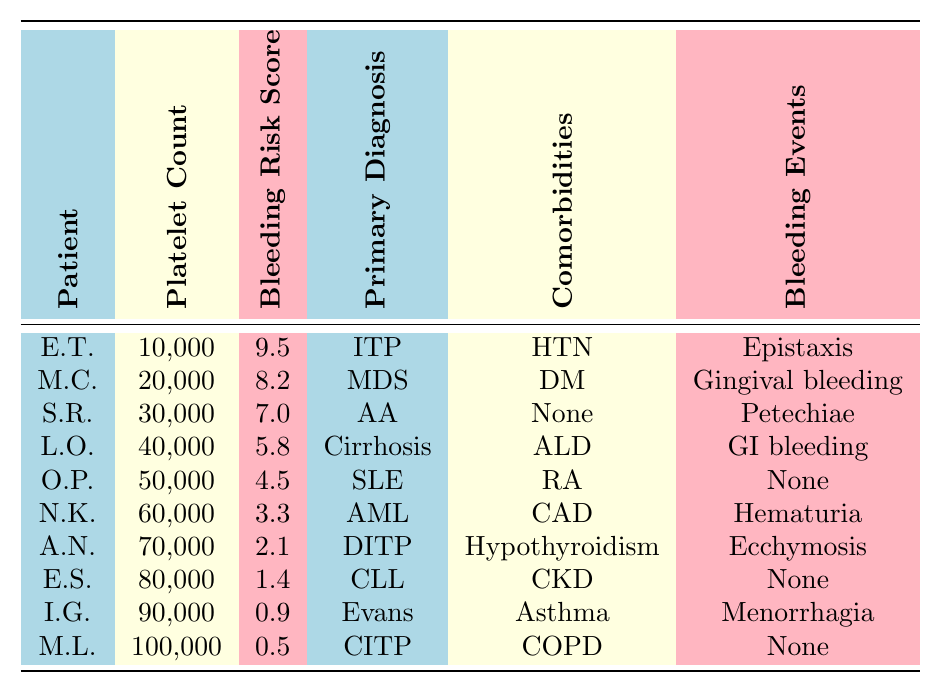What is the platelet count of Emma Thompson? The table lists Emma Thompson with a platelet count of 10,000.
Answer: 10,000 What is the bleeding risk score associated with a platelet count of 40,000? According to the table, a platelet count of 40,000 corresponds to a bleeding risk score of 5.8.
Answer: 5.8 Which patient has the highest bleeding risk score? By looking at the bleeding risk scores, Emma Thompson has the highest score at 9.5.
Answer: Emma Thompson How many patients have a platelet count below 50,000? The patients with platelet counts below 50,000 are Emma Thompson, Michael Chen, Sophia Rodriguez, and Liam O'Connor, making a total of 4.
Answer: 4 What is the average bleeding risk score for patients with platelet counts above 60,000? The patients with counts above 60,000 are Noah Kim, Ava Nguyen, Ethan Singh, Isabella Gonzalez, and Mason Lee, with scores of 3.3, 2.1, 1.4, 0.9, and 0.5, respectively. Their total score is 3.3 + 2.1 + 1.4 + 0.9 + 0.5 = 8.2, and there are 5 patients, so the average is 8.2/5 = 1.64.
Answer: 1.64 Is there any patient with a bleeding event listed as 'None'? From the table, both Olivia Patel and Ethan Singh have 'None' listed as their bleeding events.
Answer: Yes What is the gender of the patient with the lowest platelet count? The patient with the lowest platelet count is Emma Thompson, who is female.
Answer: Female How does the bleeding risk score change with each increase of 10,000 in platelet count? Analyzing the scores shows a decrease from 9.5 (10,000) to 0.5 (100,000), indicating a general trend of decreasing scores as platelet count increases. The scores decrease by approximately 1.0 for each 10,000 increase in platelet count.
Answer: Decreases by approximately 1.0 for each 10,000 increase Which primary diagnosis is associated with the patient who has the second highest bleeding risk score? The patient with the second highest bleeding risk score is Michael Chen, who has myelodysplastic syndrome as his primary diagnosis.
Answer: Myelodysplastic syndrome What comorbidity is associated with the patient who had 'hematuria' as a bleeding event? Noah Kim had 'hematuria' as a bleeding event, and he has coronary artery disease listed as his comorbidity.
Answer: Coronary artery disease What is the platelet count range across all patients? The platelet counts range from a minimum of 10,000 (Emma Thompson) to a maximum of 100,000 (Mason Lee). Therefore, the range is 10,000 to 100,000.
Answer: 10,000 to 100,000 